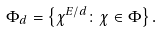Convert formula to latex. <formula><loc_0><loc_0><loc_500><loc_500>\Phi _ { d } = \left \{ \chi ^ { E / d } \colon \chi \in \Phi \right \} .</formula> 